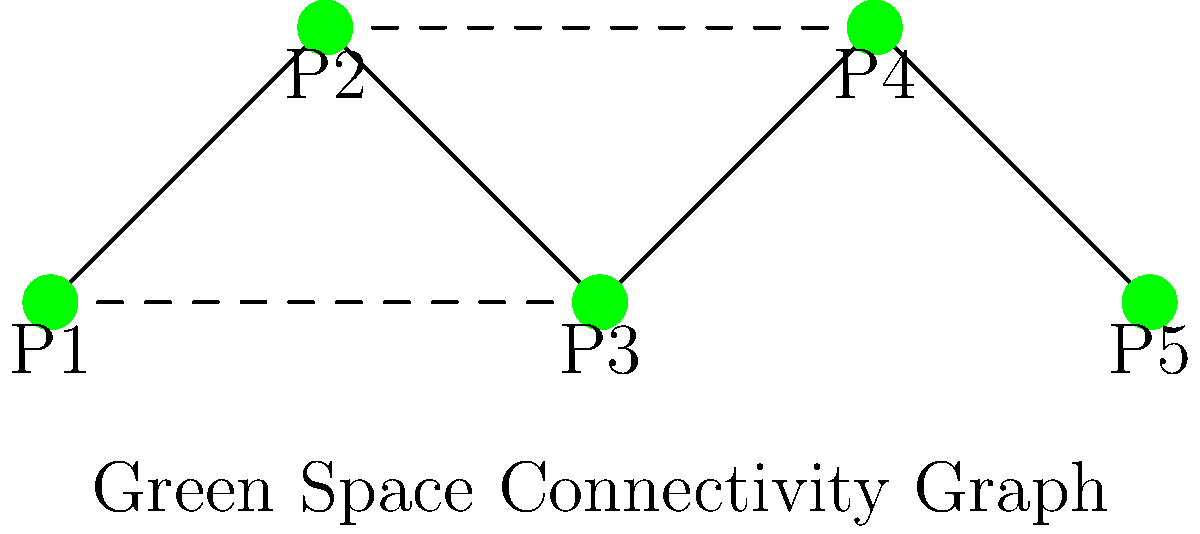As a city council member, you're presented with a graph representing the connectivity of green spaces in your city. The graph shows 5 parks (P1 to P5) connected by solid lines (existing paths) and dashed lines (proposed new connections). What is the current path length between P1 and P5, and how would it change if the proposed connections were implemented? Let's approach this step-by-step:

1. Current path length:
   - The current path follows solid lines only.
   - The path from P1 to P5 is: P1 → P2 → P3 → P4 → P5
   - This path visits 5 parks, so the path length is 4 edges.

2. Path length with proposed connections:
   - With dashed lines included, we can find a shorter path.
   - The shortest path becomes: P1 → P3 → P4 → P5
   - This new path visits 4 parks, so the path length is 3 edges.

3. Change in path length:
   - Original path length: 4 edges
   - New path length: 3 edges
   - Change: 4 - 3 = 1 edge reduction

4. Interpretation:
   - The proposed connections would reduce the path length by 1 edge.
   - This represents a 25% reduction in the path length (1/4 = 0.25 or 25%).

The implementation of the proposed connections would improve the overall connectivity of the green spaces, making it easier for citizens to access different parks in fewer steps.
Answer: Current path length: 4; New path length: 3; Reduction: 1 edge (25% improvement) 